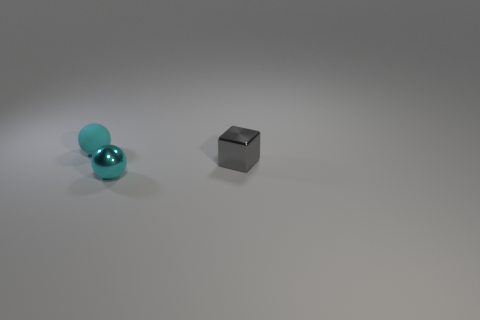Are there fewer small gray metal things that are on the left side of the gray metal object than small shiny blocks?
Offer a terse response. Yes. Are there any blue shiny cubes of the same size as the shiny ball?
Offer a very short reply. No. The tiny metal ball has what color?
Your response must be concise. Cyan. How many objects are either tiny gray objects or big metal balls?
Offer a very short reply. 1. Is the number of tiny metal objects in front of the gray block the same as the number of matte things?
Your answer should be very brief. Yes. There is a tiny object right of the tiny metal object in front of the tiny gray object; is there a cyan object that is in front of it?
Make the answer very short. Yes. There is a object that is made of the same material as the gray cube; what is its color?
Offer a terse response. Cyan. Does the shiny thing in front of the small block have the same color as the rubber sphere?
Provide a succinct answer. Yes. What number of cylinders are tiny cyan metal things or small gray matte objects?
Provide a short and direct response. 0. There is a cyan object that is the same size as the matte ball; what shape is it?
Your response must be concise. Sphere. 